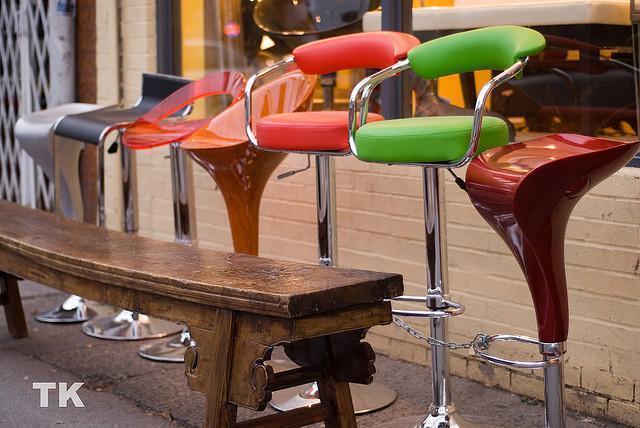What is the brown structure likely made of?
Make your selection from the four choices given to correctly answer the question.
Options: Cotton, wood, brick, metal. Wood. 